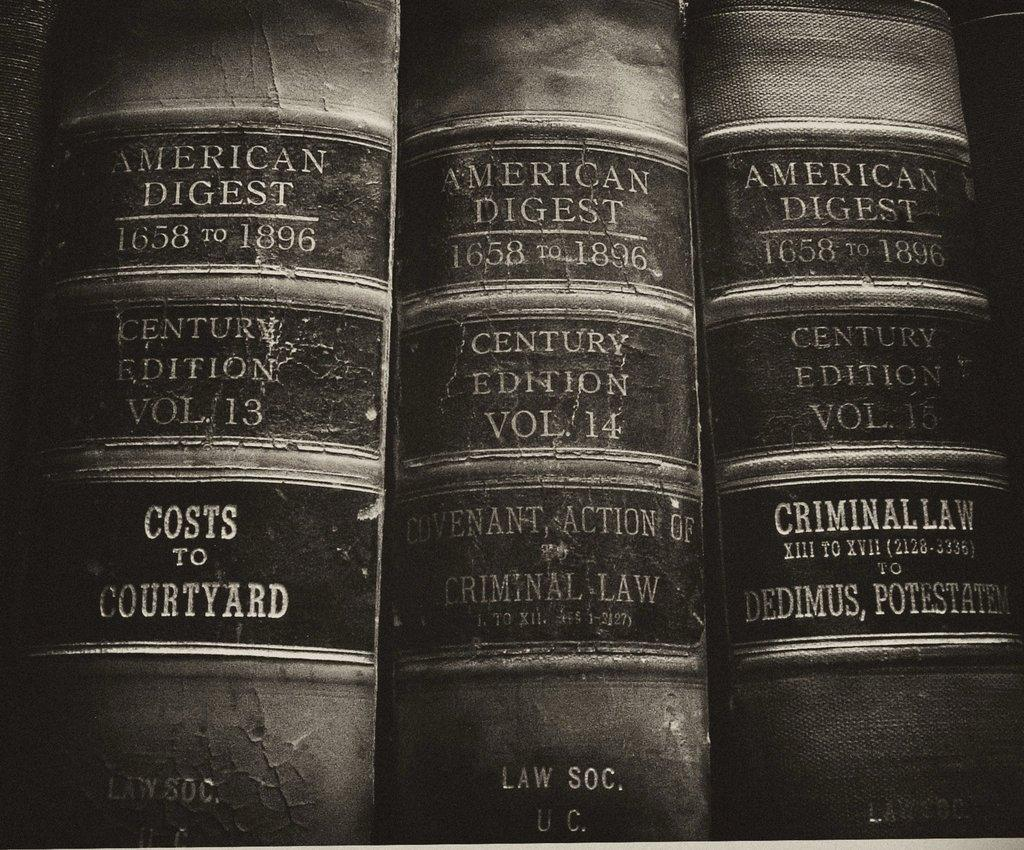<image>
Relay a brief, clear account of the picture shown. Volumes thirteen through fifteen of the American Digest book series. 